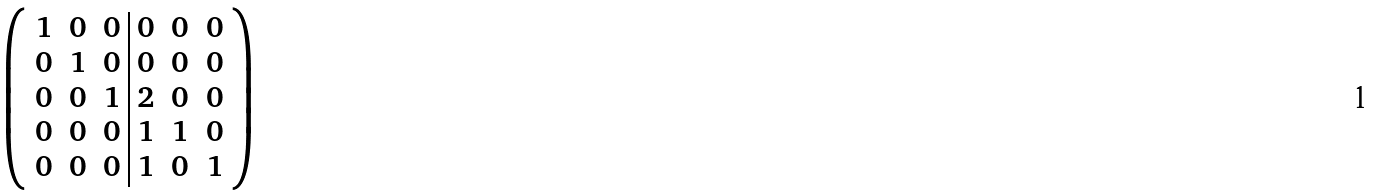Convert formula to latex. <formula><loc_0><loc_0><loc_500><loc_500>\left ( \begin{array} { c c c | c c c } 1 & 0 & 0 & 0 & 0 & 0 \\ 0 & 1 & 0 & 0 & 0 & 0 \\ 0 & 0 & 1 & 2 & 0 & 0 \\ 0 & 0 & 0 & 1 & 1 & 0 \\ 0 & 0 & 0 & 1 & 0 & 1 \\ \end{array} \right )</formula> 